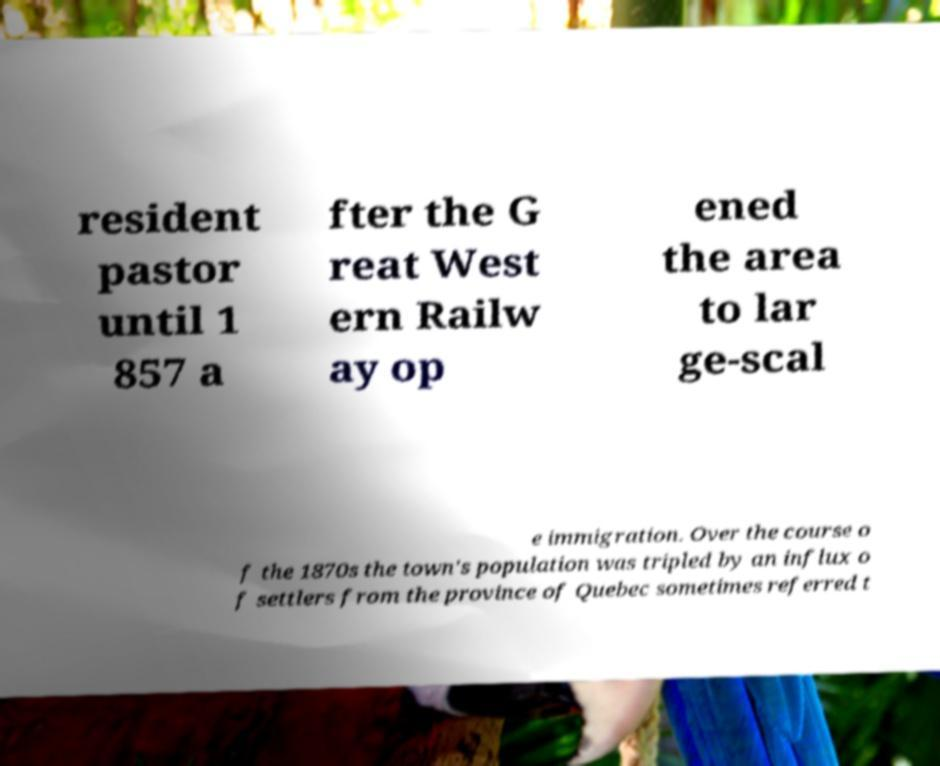Please read and relay the text visible in this image. What does it say? resident pastor until 1 857 a fter the G reat West ern Railw ay op ened the area to lar ge-scal e immigration. Over the course o f the 1870s the town's population was tripled by an influx o f settlers from the province of Quebec sometimes referred t 